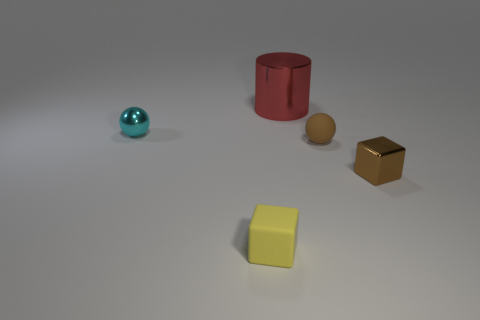Can you guess the purpose or function of these objects in this arrangement? Without additional context, it's difficult to ascertain a definitive purpose or function for these objects in their current arrangement. They could be part of a visual composition or display designed to contrast their shapes, sizes, and colors. Alternatively, they might serve as prototypes or models for educational purposes, perhaps to teach about geometry, materials, or color theory. The setup may also be intended purely for aesthetic examination or as objects in a photographic still life. 